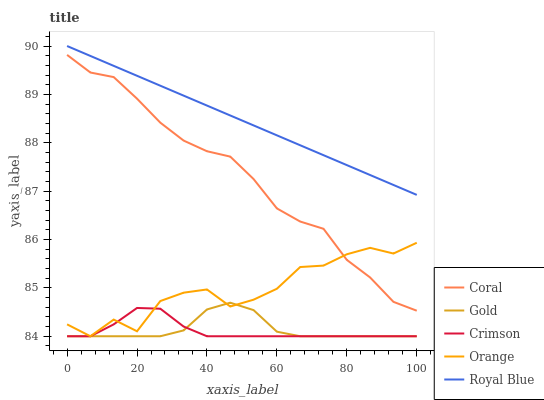Does Crimson have the minimum area under the curve?
Answer yes or no. Yes. Does Royal Blue have the maximum area under the curve?
Answer yes or no. Yes. Does Orange have the minimum area under the curve?
Answer yes or no. No. Does Orange have the maximum area under the curve?
Answer yes or no. No. Is Royal Blue the smoothest?
Answer yes or no. Yes. Is Orange the roughest?
Answer yes or no. Yes. Is Coral the smoothest?
Answer yes or no. No. Is Coral the roughest?
Answer yes or no. No. Does Crimson have the lowest value?
Answer yes or no. Yes. Does Coral have the lowest value?
Answer yes or no. No. Does Royal Blue have the highest value?
Answer yes or no. Yes. Does Orange have the highest value?
Answer yes or no. No. Is Crimson less than Coral?
Answer yes or no. Yes. Is Royal Blue greater than Coral?
Answer yes or no. Yes. Does Orange intersect Crimson?
Answer yes or no. Yes. Is Orange less than Crimson?
Answer yes or no. No. Is Orange greater than Crimson?
Answer yes or no. No. Does Crimson intersect Coral?
Answer yes or no. No. 